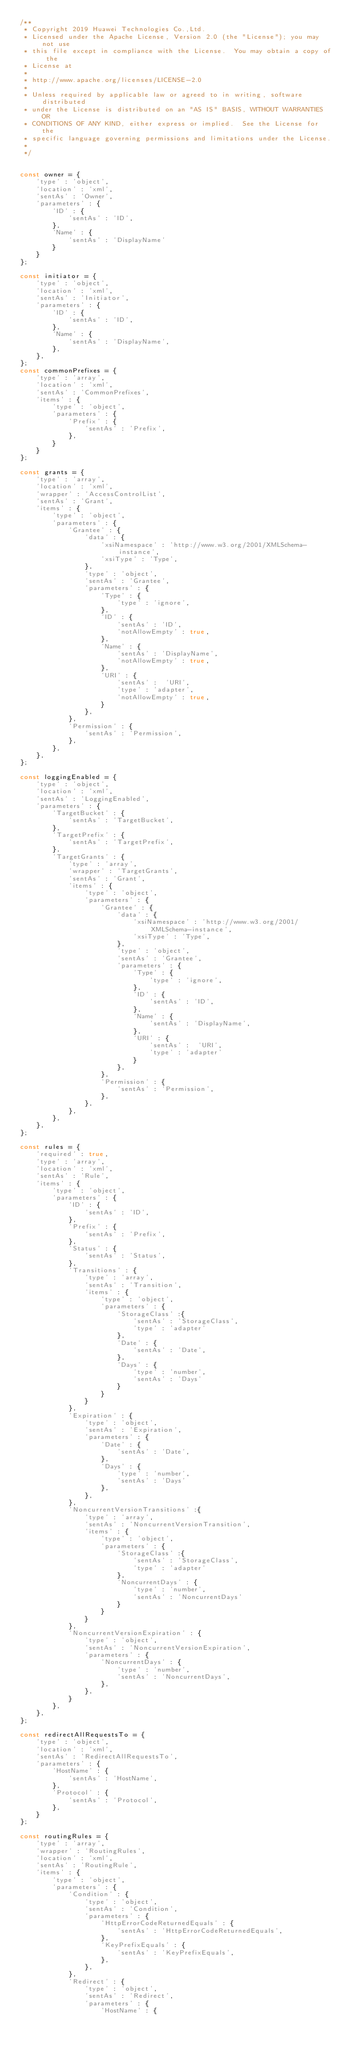<code> <loc_0><loc_0><loc_500><loc_500><_JavaScript_>/**
 * Copyright 2019 Huawei Technologies Co.,Ltd.
 * Licensed under the Apache License, Version 2.0 (the "License"); you may not use
 * this file except in compliance with the License.  You may obtain a copy of the
 * License at
 *
 * http://www.apache.org/licenses/LICENSE-2.0
 *
 * Unless required by applicable law or agreed to in writing, software distributed
 * under the License is distributed on an "AS IS" BASIS, WITHOUT WARRANTIES OR
 * CONDITIONS OF ANY KIND, either express or implied.  See the License for the
 * specific language governing permissions and limitations under the License.
 *
 */


const owner = {
	'type' : 'object',
	'location' : 'xml',
	'sentAs' : 'Owner',
	'parameters' : {
		'ID' : {
			'sentAs' : 'ID',
		},
		'Name' : {
			'sentAs' : 'DisplayName'
		}
	}
};

const initiator = {
	'type' : 'object',
	'location' : 'xml',
	'sentAs' : 'Initiator',
	'parameters' : {
		'ID' : {
			'sentAs' : 'ID',
		},
		'Name' : {
			'sentAs' : 'DisplayName',
		},
	},
};
const commonPrefixes = {
	'type' : 'array',
	'location' : 'xml',
	'sentAs' : 'CommonPrefixes',
	'items' : {
		'type' : 'object',
		'parameters' : {
			'Prefix' : {
				'sentAs' : 'Prefix',
			},
		}
	}
};

const grants = {
	'type' : 'array',
	'location' : 'xml',
	'wrapper' : 'AccessControlList',
	'sentAs' : 'Grant',
	'items' : {
		'type' : 'object',
		'parameters' : {
			'Grantee' : {
				'data' : {
					'xsiNamespace' : 'http://www.w3.org/2001/XMLSchema-instance',
					'xsiType' : 'Type',
				},
				'type' : 'object',
				'sentAs' : 'Grantee',
				'parameters' : {
					'Type' : {
						'type' : 'ignore',
					},
					'ID' : {
						'sentAs' : 'ID',
						'notAllowEmpty' : true,
					},
					'Name' : {
						'sentAs' : 'DisplayName',
						'notAllowEmpty' : true,
					},
					'URI' : {
						'sentAs' :  'URI',
						'type' : 'adapter',
						'notAllowEmpty' : true,
					}
				},
			},
			'Permission' : {
				'sentAs' : 'Permission',
			},
		},
	},
};

const loggingEnabled = {
	'type' : 'object',
	'location' : 'xml',
	'sentAs' : 'LoggingEnabled',
	'parameters' : {
		'TargetBucket' : {
			'sentAs' : 'TargetBucket',
		},
		'TargetPrefix' : {
			'sentAs' : 'TargetPrefix',
		},
		'TargetGrants' : {
			'type' : 'array',
			'wrapper' : 'TargetGrants',
			'sentAs' : 'Grant',
			'items' : {
				'type' : 'object',
				'parameters' : {
					'Grantee' : {
						'data' : {
							'xsiNamespace' : 'http://www.w3.org/2001/XMLSchema-instance',
							'xsiType' : 'Type',
						},
						'type' : 'object',
						'sentAs' : 'Grantee',
						'parameters' : {
							'Type' : {
								'type' : 'ignore',
							},
							'ID' : {
								'sentAs' : 'ID',
							},
							'Name' : {
								'sentAs' : 'DisplayName',
							},
							'URI' : {
								'sentAs' :  'URI',
								'type' : 'adapter'
							}
						},
					},
					'Permission' : {
						'sentAs' : 'Permission',
					},
				},
			},
		},
	},
};

const rules = {
	'required' : true,
	'type' : 'array',
	'location' : 'xml',
	'sentAs' : 'Rule',
	'items' : {
		'type' : 'object',
		'parameters' : {
			'ID' : {
				'sentAs' : 'ID',
			},
			'Prefix' : {
				'sentAs' : 'Prefix',
			},
			'Status' : {
				'sentAs' : 'Status',
			},
			'Transitions' : {
				'type' : 'array',
				'sentAs' : 'Transition',
				'items' : {
					'type' : 'object',
					'parameters' : {
						'StorageClass' :{
							'sentAs' : 'StorageClass',
							'type' : 'adapter'
						},
						'Date' : {
							'sentAs' : 'Date',
						},
						'Days' : {
							'type' : 'number',
							'sentAs' : 'Days'
						}
					}
				}
			},
			'Expiration' : {
				'type' : 'object',
				'sentAs' : 'Expiration',
				'parameters' : {
					'Date' : {
						'sentAs' : 'Date',
					},
					'Days' : {
						'type' : 'number',
						'sentAs' : 'Days'
					},
				},
			},
			'NoncurrentVersionTransitions' :{
				'type' : 'array',
				'sentAs' : 'NoncurrentVersionTransition',
				'items' : {
					'type' : 'object',
					'parameters' : {
						'StorageClass' :{
							'sentAs' : 'StorageClass',
							'type' : 'adapter'
						},
						'NoncurrentDays' : {
							'type' : 'number',
							'sentAs' : 'NoncurrentDays'
						}
					}
				}
			},
			'NoncurrentVersionExpiration' : {
				'type' : 'object',
				'sentAs' : 'NoncurrentVersionExpiration',
				'parameters' : {
					'NoncurrentDays' : {
						'type' : 'number',
						'sentAs' : 'NoncurrentDays',
					},
				},
			}
		},
	},
};

const redirectAllRequestsTo = {
	'type' : 'object',
	'location' : 'xml',
	'sentAs' : 'RedirectAllRequestsTo',
	'parameters' : {
		'HostName' : {
			'sentAs' : 'HostName',
		},
		'Protocol' : {
			'sentAs' : 'Protocol',
		},
	}
};

const routingRules = {
	'type' : 'array',
	'wrapper' : 'RoutingRules',
	'location' : 'xml',
	'sentAs' : 'RoutingRule',
	'items' : {
		'type' : 'object',
		'parameters' : {
			'Condition' : {
				'type' : 'object',
				'sentAs' : 'Condition',
				'parameters' : {
					'HttpErrorCodeReturnedEquals' : {
						'sentAs' : 'HttpErrorCodeReturnedEquals',
					},
					'KeyPrefixEquals' : {
						'sentAs' : 'KeyPrefixEquals',
					},
				},
			},
			'Redirect' : {
				'type' : 'object',
				'sentAs' : 'Redirect',
				'parameters' : {
					'HostName' : {</code> 